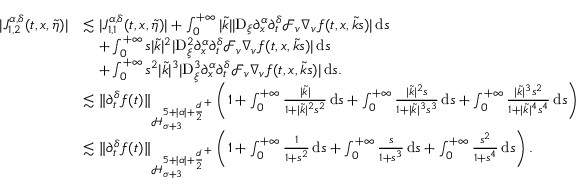<formula> <loc_0><loc_0><loc_500><loc_500>\begin{array} { r l } { | J _ { 1 , 2 } ^ { \alpha , \delta } ( t , x , \widetilde { \eta } ) | } & { \lesssim | J _ { 1 , 1 } ^ { \alpha , \delta } ( t , x , \widetilde { \eta } ) | + \int _ { 0 } ^ { + \infty } | \widetilde { k } | | D _ { \xi } \partial _ { x } ^ { \alpha } \partial _ { t } ^ { \delta } \mathcal { F } _ { v } \nabla _ { v } f ( t , x , \widetilde { k } s ) | \, d s } \\ & { \quad + \int _ { 0 } ^ { + \infty } s | \widetilde { k } | ^ { 2 } | D _ { \xi } ^ { 2 } \partial _ { x } ^ { \alpha } \partial _ { t } ^ { \delta } \mathcal { F } _ { v } \nabla _ { v } f ( t , x , \widetilde { k } s ) | \, d s } \\ & { \quad + \int _ { 0 } ^ { + \infty } s ^ { 2 } | \widetilde { k } | ^ { 3 } | D _ { \xi } ^ { 3 } \partial _ { x } ^ { \alpha } \partial _ { t } ^ { \delta } \mathcal { F } _ { v } \nabla _ { v } f ( t , x , \widetilde { k } s ) | \, d s . } \\ & { \lesssim \| \partial _ { t } ^ { \delta } f ( t ) \| _ { \mathcal { H } _ { \sigma + 3 } ^ { 5 + | \alpha | + { \frac { d } { 2 } } ^ { + } } } \left ( 1 + \int _ { 0 } ^ { + \infty } \frac { | \widetilde { k } | } { 1 + | \widetilde { k } | ^ { 2 } s ^ { 2 } } \, d s + \int _ { 0 } ^ { + \infty } \frac { | \widetilde { k } | ^ { 2 } s } { 1 + | \widetilde { k } | ^ { 3 } s ^ { 3 } } \, d s + \int _ { 0 } ^ { + \infty } \frac { | \widetilde { k } | ^ { 3 } s ^ { 2 } } { 1 + | \widetilde { k } | ^ { 4 } s ^ { 4 } } \, d s \right ) } \\ & { \lesssim \| \partial _ { t } ^ { \delta } f ( t ) \| _ { \mathcal { H } _ { \sigma + 3 } ^ { 5 + | \alpha | + { \frac { d } { 2 } } ^ { + } } } \left ( 1 + \int _ { 0 } ^ { + \infty } \frac { 1 } { 1 + s ^ { 2 } } \, d s + \int _ { 0 } ^ { + \infty } \frac { s } { 1 + s ^ { 3 } } \, d s + \int _ { 0 } ^ { + \infty } \frac { s ^ { 2 } } { 1 + s ^ { 4 } } \, d s \right ) . } \end{array}</formula> 